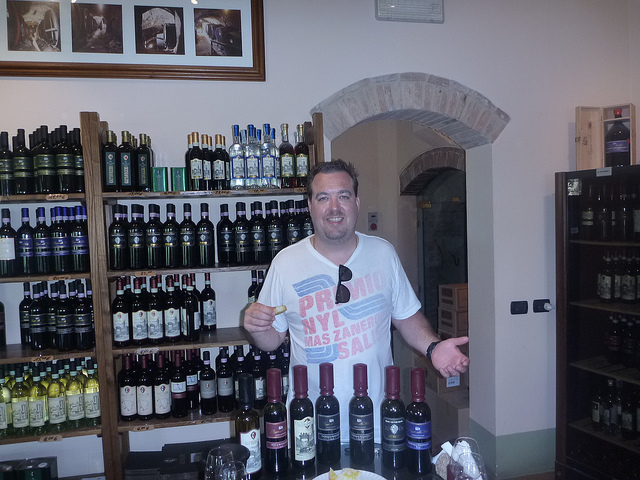Can you tell me more about the setting in which the man is standing? Certainly! The man is standing in an indoor setting with stone archways and wooden shelves lined with an array of bottles. The variety includes both dark and light colored liquids, possibly wine and spirits or vinegars and oils, implying a setting like a winery's tasting room, gourmet shop, or a delicatessen. 